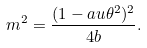<formula> <loc_0><loc_0><loc_500><loc_500>m ^ { 2 } = \frac { ( 1 - a u \theta ^ { 2 } ) ^ { 2 } } { 4 b } .</formula> 